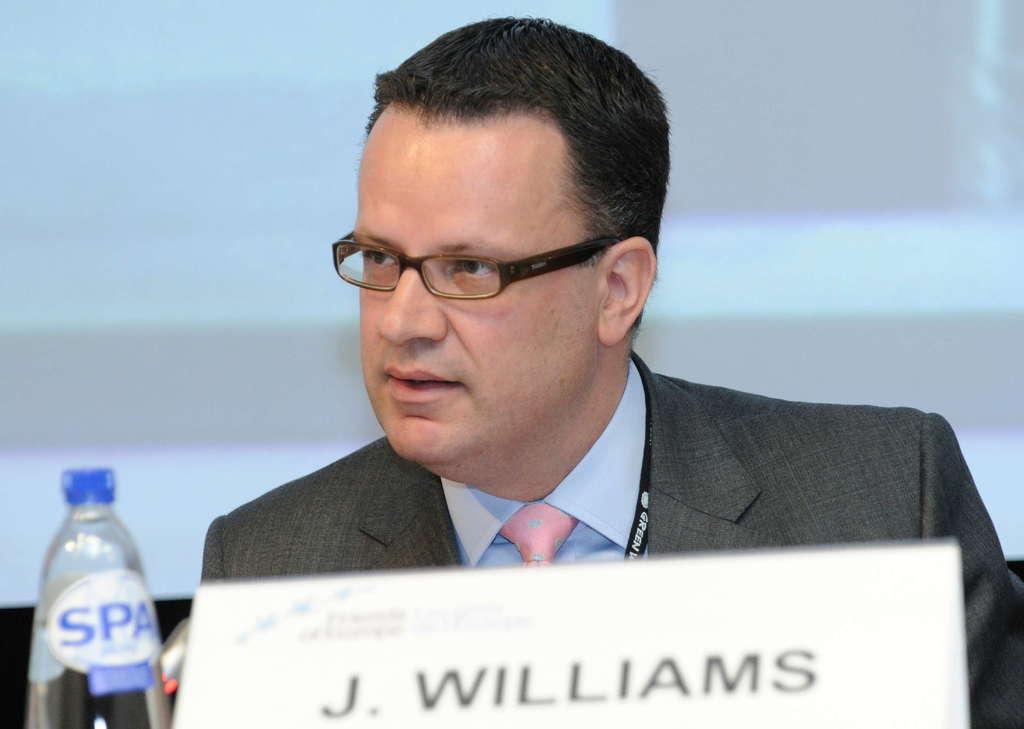Could you give a brief overview of what you see in this image? in the picture there was a person ,in front of the person there was a bottle and beside the bottle there was a name card in which we can see the words j. williams. 